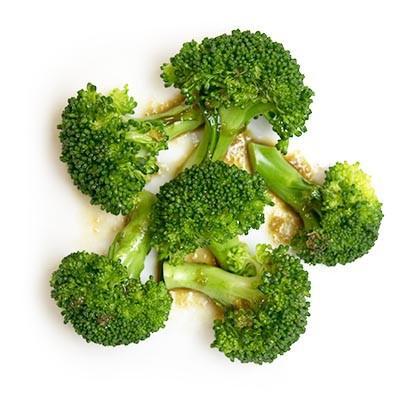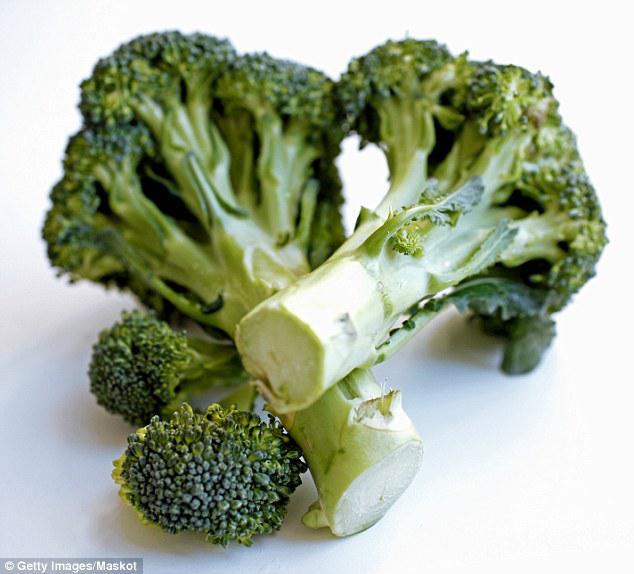The first image is the image on the left, the second image is the image on the right. For the images shown, is this caption "There are no more than four broccoli pieces" true? Answer yes or no. No. 